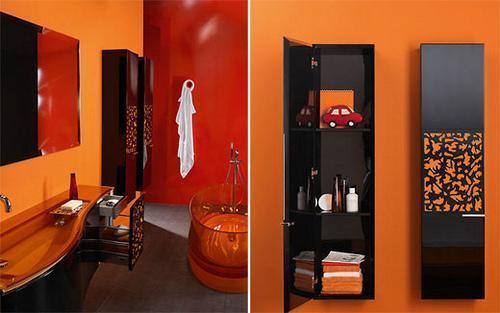How many cupboards are on the orange wall on the right side?
Give a very brief answer. 2. 